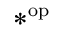<formula> <loc_0><loc_0><loc_500><loc_500>* ^ { o p }</formula> 